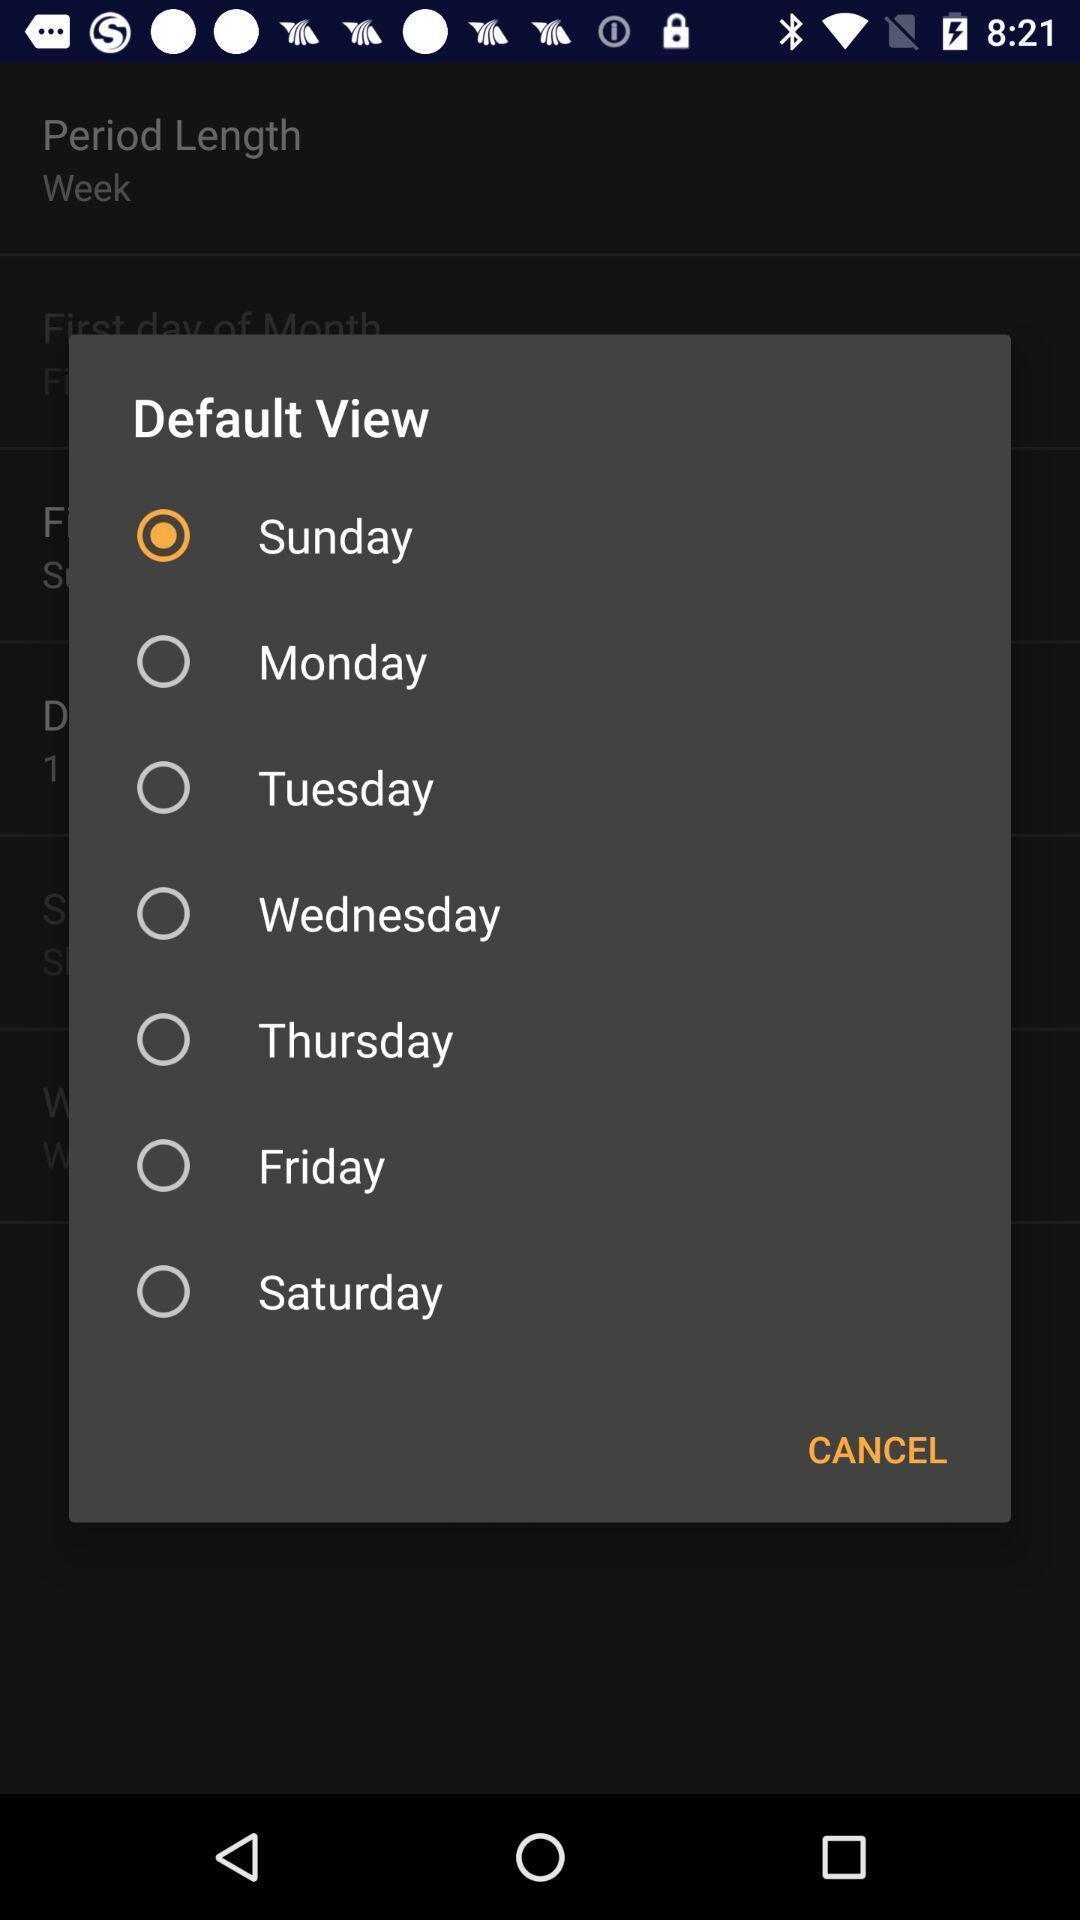Summarize the information in this screenshot. Screen shows default view list. 